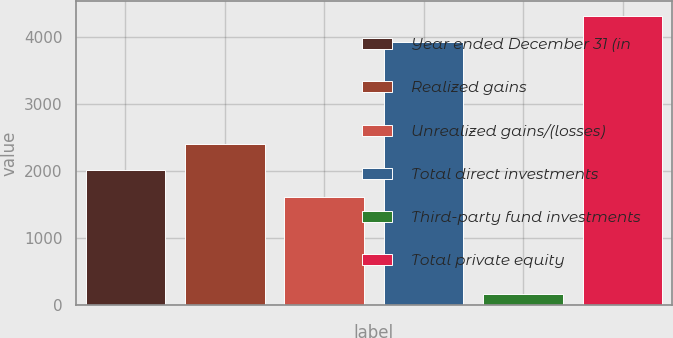Convert chart. <chart><loc_0><loc_0><loc_500><loc_500><bar_chart><fcel>Year ended December 31 (in<fcel>Realized gains<fcel>Unrealized gains/(losses)<fcel>Total direct investments<fcel>Third-party fund investments<fcel>Total private equity<nl><fcel>2007<fcel>2398.9<fcel>1607<fcel>3919<fcel>165<fcel>4310.9<nl></chart> 